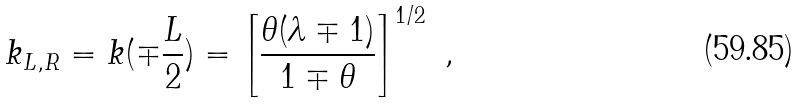<formula> <loc_0><loc_0><loc_500><loc_500>k _ { L , R } = k ( \mp \frac { L } { 2 } ) = \left [ \frac { \theta ( \lambda \mp 1 ) } { 1 \mp \theta } \right ] ^ { 1 / 2 } \ ,</formula> 